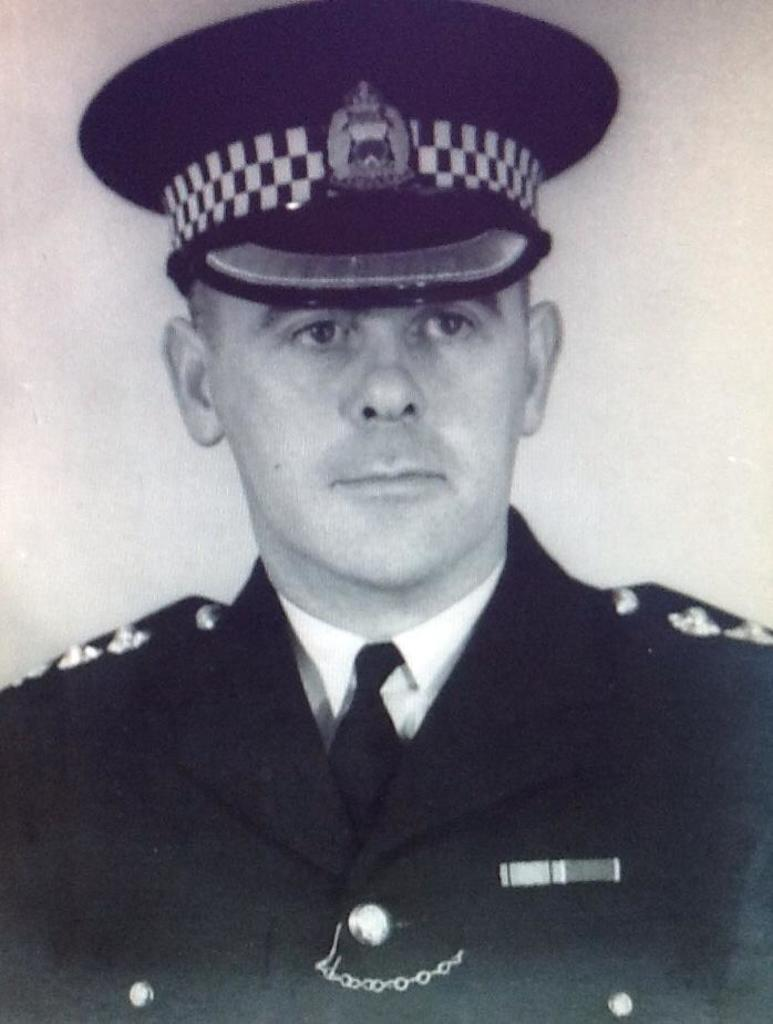What is the main subject in the foreground of the image? There is a man in the foreground of the image. What type of clothing is the man wearing? The man is wearing a coat, a tie, and a cap on his head. What type of trouble is the man causing in the image? There is no indication of trouble or any negative actions in the image; the man is simply standing there wearing a coat, tie, and cap. 